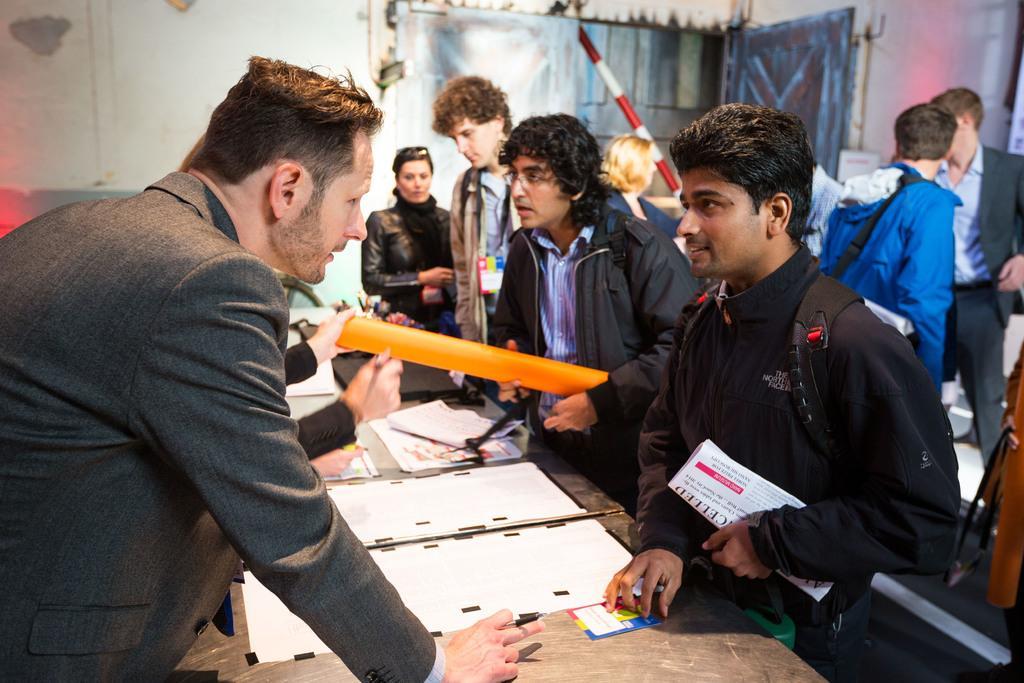In one or two sentences, can you explain what this image depicts? In this image we can see many people. There are tables. On the tables there are papers and some other items. Some people are holding something in the hand. In the background there is a wall. Also there is a rod. 